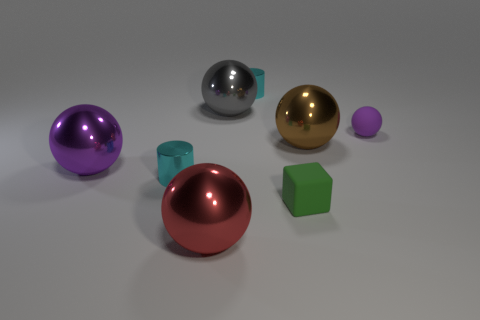What is the material of the object that is the same color as the tiny ball?
Your answer should be very brief. Metal. What is the color of the tiny matte ball?
Your answer should be compact. Purple. Is there a big gray metal ball right of the small thing on the right side of the green matte block?
Your answer should be very brief. No. What is the material of the tiny purple object?
Your response must be concise. Rubber. Are the purple thing that is to the right of the green block and the thing that is in front of the cube made of the same material?
Your answer should be compact. No. Are there any other things that have the same color as the small cube?
Your answer should be very brief. No. What color is the rubber object that is the same shape as the large brown metallic thing?
Provide a short and direct response. Purple. What size is the sphere that is behind the purple metal sphere and to the left of the matte block?
Ensure brevity in your answer.  Large. There is a tiny cyan thing in front of the big gray sphere; does it have the same shape as the large object that is in front of the large purple thing?
Provide a succinct answer. No. What number of cubes have the same material as the big red object?
Offer a very short reply. 0. 